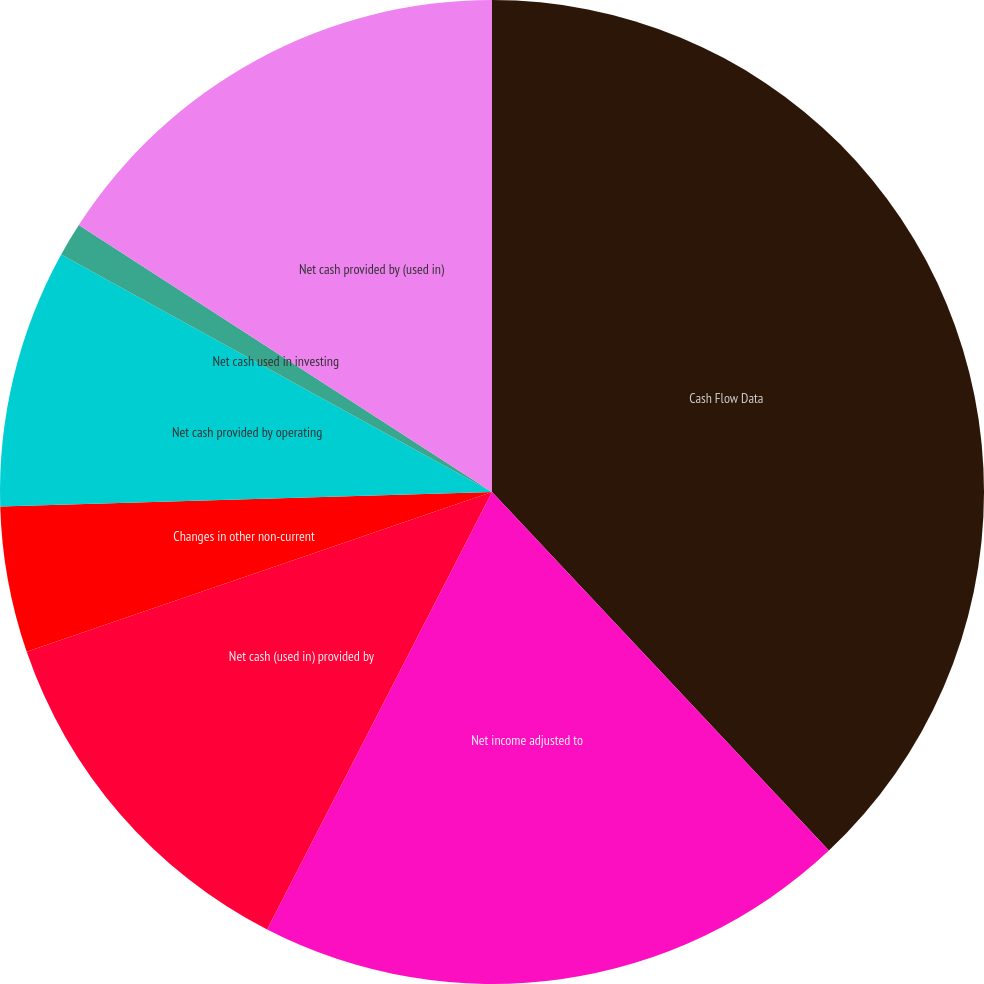Convert chart to OTSL. <chart><loc_0><loc_0><loc_500><loc_500><pie_chart><fcel>Cash Flow Data<fcel>Net income adjusted to<fcel>Net cash (used in) provided by<fcel>Changes in other non-current<fcel>Net cash provided by operating<fcel>Net cash used in investing<fcel>Net cash provided by (used in)<nl><fcel>38.0%<fcel>19.56%<fcel>12.18%<fcel>4.8%<fcel>8.49%<fcel>1.11%<fcel>15.87%<nl></chart> 